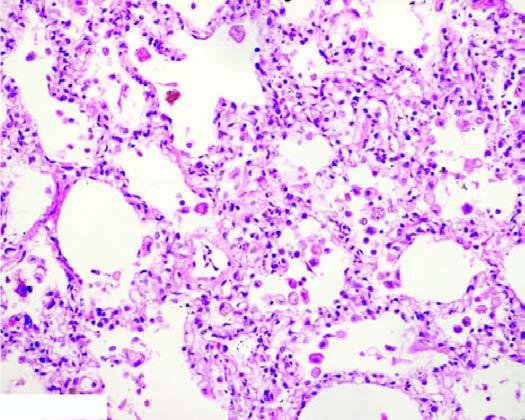why are the alveolar septa widened?
Answer the question using a single word or phrase. Due to congestion 